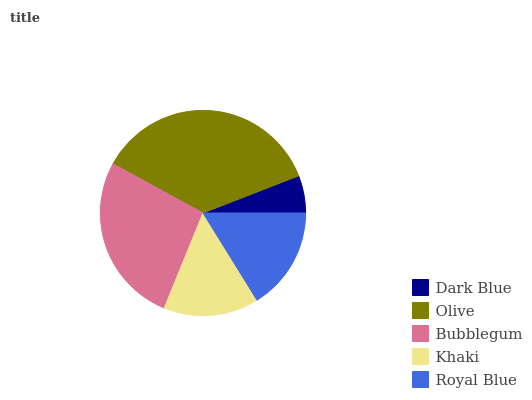Is Dark Blue the minimum?
Answer yes or no. Yes. Is Olive the maximum?
Answer yes or no. Yes. Is Bubblegum the minimum?
Answer yes or no. No. Is Bubblegum the maximum?
Answer yes or no. No. Is Olive greater than Bubblegum?
Answer yes or no. Yes. Is Bubblegum less than Olive?
Answer yes or no. Yes. Is Bubblegum greater than Olive?
Answer yes or no. No. Is Olive less than Bubblegum?
Answer yes or no. No. Is Royal Blue the high median?
Answer yes or no. Yes. Is Royal Blue the low median?
Answer yes or no. Yes. Is Bubblegum the high median?
Answer yes or no. No. Is Khaki the low median?
Answer yes or no. No. 